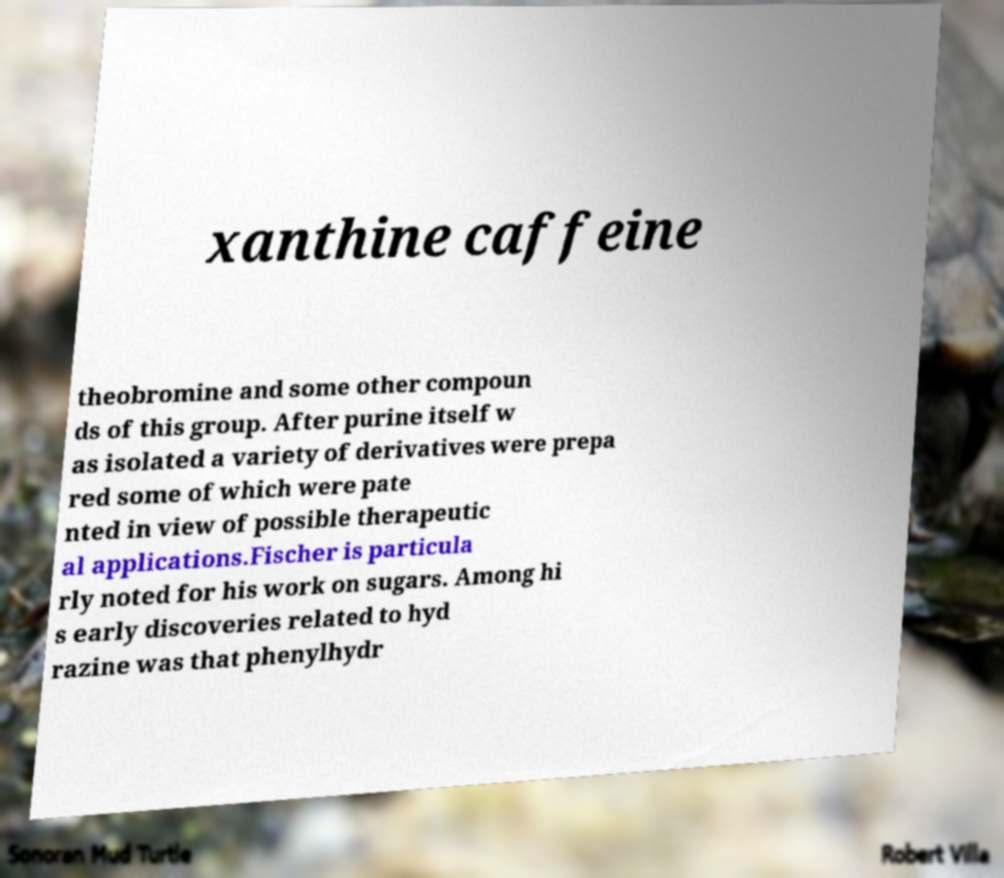Could you extract and type out the text from this image? xanthine caffeine theobromine and some other compoun ds of this group. After purine itself w as isolated a variety of derivatives were prepa red some of which were pate nted in view of possible therapeutic al applications.Fischer is particula rly noted for his work on sugars. Among hi s early discoveries related to hyd razine was that phenylhydr 